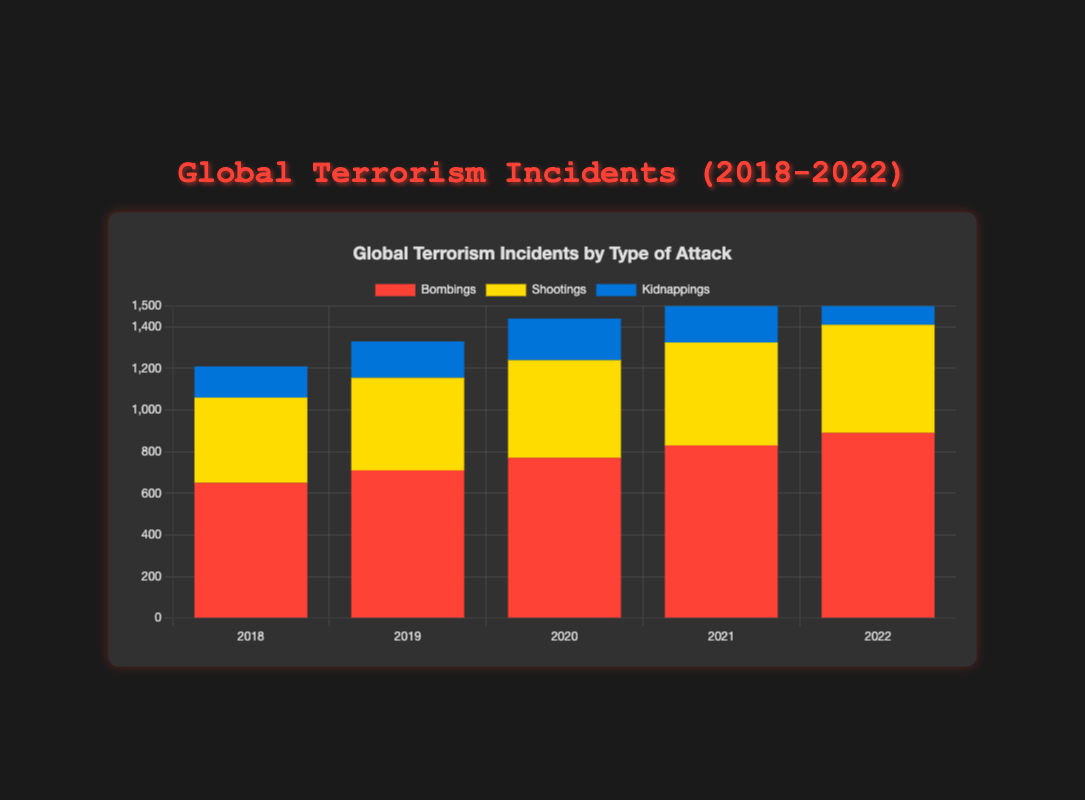What's the most frequent type of attack in 2022? The heights of the bars for each type of attack in 2022 indicate frequency. The red bar representing bombings is the tallest among all attack types.
Answer: Bombings Which year witnessed the highest number of bombings? By comparing the heights of red bars representing bombings across all years, 2022 has the tallest red bar.
Answer: 2022 How did the frequency of shootings change from 2018 to 2022? The yellow bars representing shootings show an increasing height from 2018 to 2022, indicating an increase in frequency.
Answer: Increased Which region had the highest cumulative number of kidnappings over five years? By summing up relevant data points for kidnappings (blue bars) across all years for each region, Subsaharan Africa has the highest cumulative total.
Answer: Subsaharan Africa What is the total number of incidents in 2020? Sum the heights of all bars in 2020. Bombings: 550 + 220, Shootings: 370 + 100, Kidnappings: 140 + 60. Total: 1270 + 470 + 200 = 1940.
Answer: 1940 In which year did the difference between the number of bombings and shootings is the largest? For each year calculate the absolute difference between heights of red (bombings) and yellow (shootings) bars. The largest difference is in 2022: 650 - 410 = 240.
Answer: 2022 What were the visual trends in kidnappings from 2018 to 2022? The heights of blue bars representing kidnappings show a gradual increase each year from 2018 to 2022.
Answer: Gradual increase How many more incidents were there in Western Europe compared to North America in 2019 considering all types of attacks? Sum of incidents in 2019 for Western Europe: 210 (bombings), 95 (shootings) = 305. For North America: 210. Difference: 305 - 95 = 210.
Answer: 210 What was the average number of bombings per year in the Middle East from 2018 to 2022? Sum the heights of red bars representing bombings for the Middle East each year and divide by 5. (450+500+550+600+650)/5 = 550.
Answer: 550 